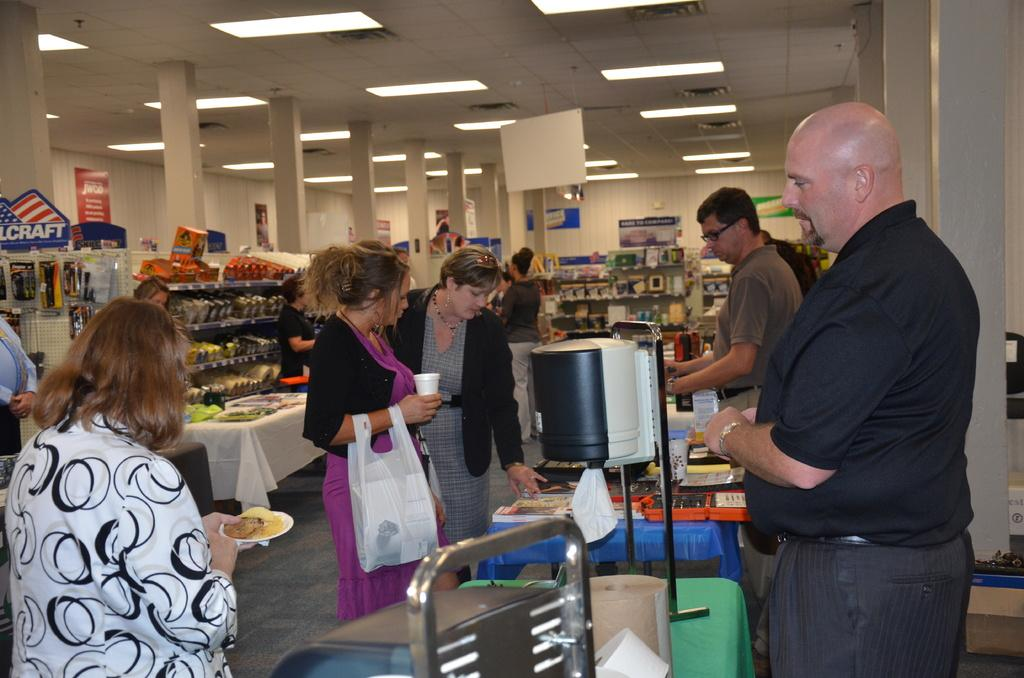How many people are in the image? There is a group of people in the image. Where are the people located? The people are standing in a store. What can be seen in the image besides the people? There are lights visible in the image, as well as objects in the racks and boards on the wall. What type of prose is being recited by the people in the image? There is no indication in the image that the people are reciting any prose. Can you describe the motion of the soup in the image? There is no soup present in the image, so it is not possible to describe its motion. 